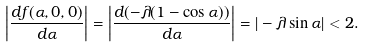<formula> <loc_0><loc_0><loc_500><loc_500>\left | \frac { d f ( \alpha , 0 , 0 ) } { d \alpha } \right | = \left | \frac { d ( - \lambda ( 1 - \cos \alpha ) ) } { d \alpha } \right | = | - \lambda \sin \alpha | < 2 .</formula> 